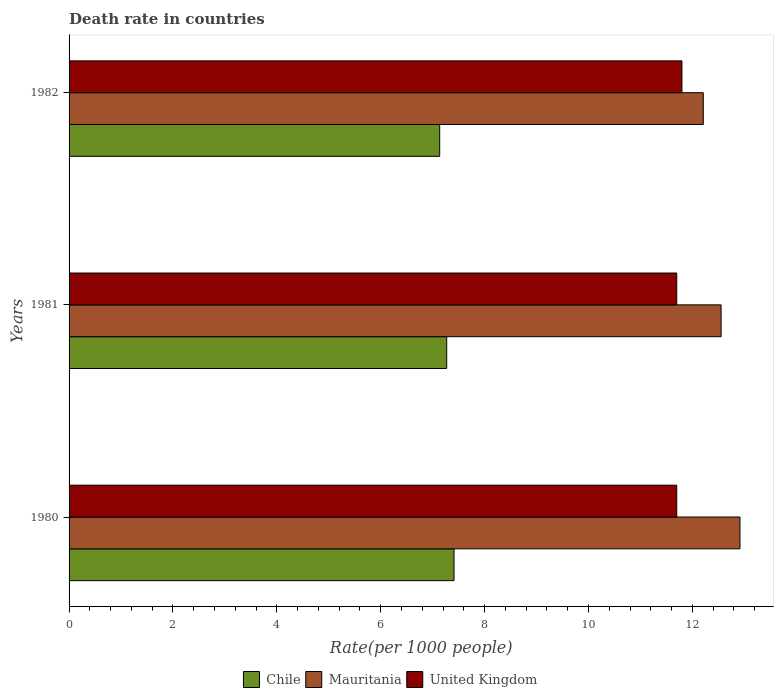Are the number of bars per tick equal to the number of legend labels?
Provide a short and direct response. Yes. In how many cases, is the number of bars for a given year not equal to the number of legend labels?
Make the answer very short. 0. What is the death rate in Chile in 1980?
Keep it short and to the point. 7.41. Across all years, what is the maximum death rate in Mauritania?
Your answer should be very brief. 12.92. Across all years, what is the minimum death rate in Chile?
Provide a short and direct response. 7.14. In which year was the death rate in Mauritania minimum?
Offer a very short reply. 1982. What is the total death rate in Chile in the graph?
Give a very brief answer. 21.82. What is the difference between the death rate in United Kingdom in 1980 and that in 1981?
Offer a very short reply. 0. What is the difference between the death rate in Mauritania in 1981 and the death rate in United Kingdom in 1980?
Offer a very short reply. 0.85. What is the average death rate in Chile per year?
Your answer should be very brief. 7.27. In the year 1981, what is the difference between the death rate in Chile and death rate in United Kingdom?
Offer a very short reply. -4.43. What is the ratio of the death rate in Mauritania in 1981 to that in 1982?
Your answer should be compact. 1.03. Is the difference between the death rate in Chile in 1980 and 1981 greater than the difference between the death rate in United Kingdom in 1980 and 1981?
Offer a terse response. Yes. What is the difference between the highest and the second highest death rate in United Kingdom?
Offer a very short reply. 0.1. What is the difference between the highest and the lowest death rate in United Kingdom?
Ensure brevity in your answer.  0.1. In how many years, is the death rate in Mauritania greater than the average death rate in Mauritania taken over all years?
Ensure brevity in your answer.  1. What does the 2nd bar from the top in 1980 represents?
Keep it short and to the point. Mauritania. What does the 1st bar from the bottom in 1980 represents?
Make the answer very short. Chile. Are all the bars in the graph horizontal?
Make the answer very short. Yes. How many years are there in the graph?
Offer a very short reply. 3. What is the difference between two consecutive major ticks on the X-axis?
Make the answer very short. 2. Are the values on the major ticks of X-axis written in scientific E-notation?
Provide a short and direct response. No. How many legend labels are there?
Provide a short and direct response. 3. What is the title of the graph?
Make the answer very short. Death rate in countries. What is the label or title of the X-axis?
Offer a terse response. Rate(per 1000 people). What is the label or title of the Y-axis?
Your response must be concise. Years. What is the Rate(per 1000 people) in Chile in 1980?
Provide a succinct answer. 7.41. What is the Rate(per 1000 people) in Mauritania in 1980?
Ensure brevity in your answer.  12.92. What is the Rate(per 1000 people) of United Kingdom in 1980?
Keep it short and to the point. 11.7. What is the Rate(per 1000 people) of Chile in 1981?
Provide a short and direct response. 7.27. What is the Rate(per 1000 people) in Mauritania in 1981?
Your response must be concise. 12.55. What is the Rate(per 1000 people) of United Kingdom in 1981?
Offer a terse response. 11.7. What is the Rate(per 1000 people) in Chile in 1982?
Your response must be concise. 7.14. What is the Rate(per 1000 people) in Mauritania in 1982?
Make the answer very short. 12.21. What is the Rate(per 1000 people) of United Kingdom in 1982?
Your response must be concise. 11.8. Across all years, what is the maximum Rate(per 1000 people) of Chile?
Provide a short and direct response. 7.41. Across all years, what is the maximum Rate(per 1000 people) in Mauritania?
Keep it short and to the point. 12.92. Across all years, what is the maximum Rate(per 1000 people) of United Kingdom?
Your answer should be compact. 11.8. Across all years, what is the minimum Rate(per 1000 people) in Chile?
Your answer should be very brief. 7.14. Across all years, what is the minimum Rate(per 1000 people) in Mauritania?
Your response must be concise. 12.21. Across all years, what is the minimum Rate(per 1000 people) in United Kingdom?
Make the answer very short. 11.7. What is the total Rate(per 1000 people) of Chile in the graph?
Offer a terse response. 21.82. What is the total Rate(per 1000 people) of Mauritania in the graph?
Your answer should be compact. 37.68. What is the total Rate(per 1000 people) of United Kingdom in the graph?
Provide a short and direct response. 35.2. What is the difference between the Rate(per 1000 people) in Chile in 1980 and that in 1981?
Offer a very short reply. 0.14. What is the difference between the Rate(per 1000 people) in Mauritania in 1980 and that in 1981?
Provide a short and direct response. 0.36. What is the difference between the Rate(per 1000 people) of United Kingdom in 1980 and that in 1981?
Make the answer very short. 0. What is the difference between the Rate(per 1000 people) in Chile in 1980 and that in 1982?
Offer a very short reply. 0.28. What is the difference between the Rate(per 1000 people) of Mauritania in 1980 and that in 1982?
Make the answer very short. 0.71. What is the difference between the Rate(per 1000 people) in United Kingdom in 1980 and that in 1982?
Provide a succinct answer. -0.1. What is the difference between the Rate(per 1000 people) in Chile in 1981 and that in 1982?
Provide a succinct answer. 0.14. What is the difference between the Rate(per 1000 people) of Mauritania in 1981 and that in 1982?
Your response must be concise. 0.34. What is the difference between the Rate(per 1000 people) of United Kingdom in 1981 and that in 1982?
Your answer should be very brief. -0.1. What is the difference between the Rate(per 1000 people) of Chile in 1980 and the Rate(per 1000 people) of Mauritania in 1981?
Give a very brief answer. -5.14. What is the difference between the Rate(per 1000 people) of Chile in 1980 and the Rate(per 1000 people) of United Kingdom in 1981?
Keep it short and to the point. -4.29. What is the difference between the Rate(per 1000 people) in Mauritania in 1980 and the Rate(per 1000 people) in United Kingdom in 1981?
Offer a terse response. 1.22. What is the difference between the Rate(per 1000 people) of Chile in 1980 and the Rate(per 1000 people) of Mauritania in 1982?
Your answer should be very brief. -4.8. What is the difference between the Rate(per 1000 people) in Chile in 1980 and the Rate(per 1000 people) in United Kingdom in 1982?
Your response must be concise. -4.39. What is the difference between the Rate(per 1000 people) of Mauritania in 1980 and the Rate(per 1000 people) of United Kingdom in 1982?
Provide a succinct answer. 1.12. What is the difference between the Rate(per 1000 people) in Chile in 1981 and the Rate(per 1000 people) in Mauritania in 1982?
Your answer should be very brief. -4.94. What is the difference between the Rate(per 1000 people) of Chile in 1981 and the Rate(per 1000 people) of United Kingdom in 1982?
Provide a succinct answer. -4.53. What is the difference between the Rate(per 1000 people) of Mauritania in 1981 and the Rate(per 1000 people) of United Kingdom in 1982?
Your response must be concise. 0.75. What is the average Rate(per 1000 people) in Chile per year?
Ensure brevity in your answer.  7.27. What is the average Rate(per 1000 people) of Mauritania per year?
Ensure brevity in your answer.  12.56. What is the average Rate(per 1000 people) in United Kingdom per year?
Ensure brevity in your answer.  11.73. In the year 1980, what is the difference between the Rate(per 1000 people) in Chile and Rate(per 1000 people) in Mauritania?
Your answer should be compact. -5.5. In the year 1980, what is the difference between the Rate(per 1000 people) of Chile and Rate(per 1000 people) of United Kingdom?
Your answer should be compact. -4.29. In the year 1980, what is the difference between the Rate(per 1000 people) in Mauritania and Rate(per 1000 people) in United Kingdom?
Your response must be concise. 1.22. In the year 1981, what is the difference between the Rate(per 1000 people) in Chile and Rate(per 1000 people) in Mauritania?
Offer a terse response. -5.28. In the year 1981, what is the difference between the Rate(per 1000 people) in Chile and Rate(per 1000 people) in United Kingdom?
Offer a very short reply. -4.43. In the year 1981, what is the difference between the Rate(per 1000 people) of Mauritania and Rate(per 1000 people) of United Kingdom?
Offer a very short reply. 0.85. In the year 1982, what is the difference between the Rate(per 1000 people) in Chile and Rate(per 1000 people) in Mauritania?
Provide a short and direct response. -5.08. In the year 1982, what is the difference between the Rate(per 1000 people) in Chile and Rate(per 1000 people) in United Kingdom?
Give a very brief answer. -4.66. In the year 1982, what is the difference between the Rate(per 1000 people) in Mauritania and Rate(per 1000 people) in United Kingdom?
Your answer should be compact. 0.41. What is the ratio of the Rate(per 1000 people) of Chile in 1980 to that in 1981?
Your answer should be very brief. 1.02. What is the ratio of the Rate(per 1000 people) of Mauritania in 1980 to that in 1981?
Give a very brief answer. 1.03. What is the ratio of the Rate(per 1000 people) in United Kingdom in 1980 to that in 1981?
Give a very brief answer. 1. What is the ratio of the Rate(per 1000 people) in Chile in 1980 to that in 1982?
Offer a terse response. 1.04. What is the ratio of the Rate(per 1000 people) in Mauritania in 1980 to that in 1982?
Your response must be concise. 1.06. What is the ratio of the Rate(per 1000 people) of United Kingdom in 1980 to that in 1982?
Provide a succinct answer. 0.99. What is the ratio of the Rate(per 1000 people) in Chile in 1981 to that in 1982?
Your answer should be compact. 1.02. What is the ratio of the Rate(per 1000 people) of Mauritania in 1981 to that in 1982?
Offer a terse response. 1.03. What is the difference between the highest and the second highest Rate(per 1000 people) in Chile?
Give a very brief answer. 0.14. What is the difference between the highest and the second highest Rate(per 1000 people) in Mauritania?
Provide a succinct answer. 0.36. What is the difference between the highest and the second highest Rate(per 1000 people) in United Kingdom?
Give a very brief answer. 0.1. What is the difference between the highest and the lowest Rate(per 1000 people) in Chile?
Offer a terse response. 0.28. What is the difference between the highest and the lowest Rate(per 1000 people) in Mauritania?
Ensure brevity in your answer.  0.71. 